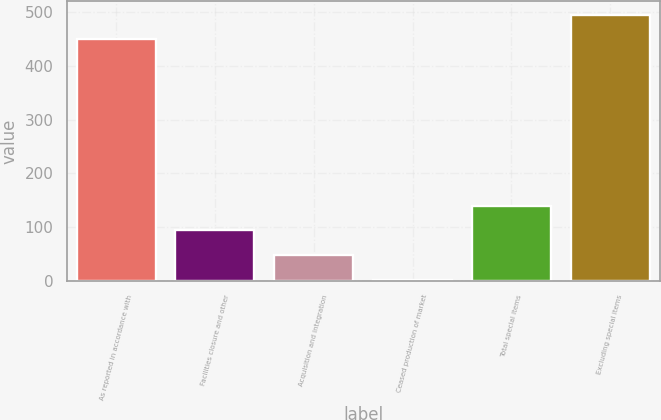Convert chart to OTSL. <chart><loc_0><loc_0><loc_500><loc_500><bar_chart><fcel>As reported in accordance with<fcel>Facilities closure and other<fcel>Acquisition and integration<fcel>Ceased production of market<fcel>Total special items<fcel>Excluding special items<nl><fcel>449.6<fcel>93.84<fcel>47.82<fcel>1.8<fcel>139.86<fcel>495.62<nl></chart> 